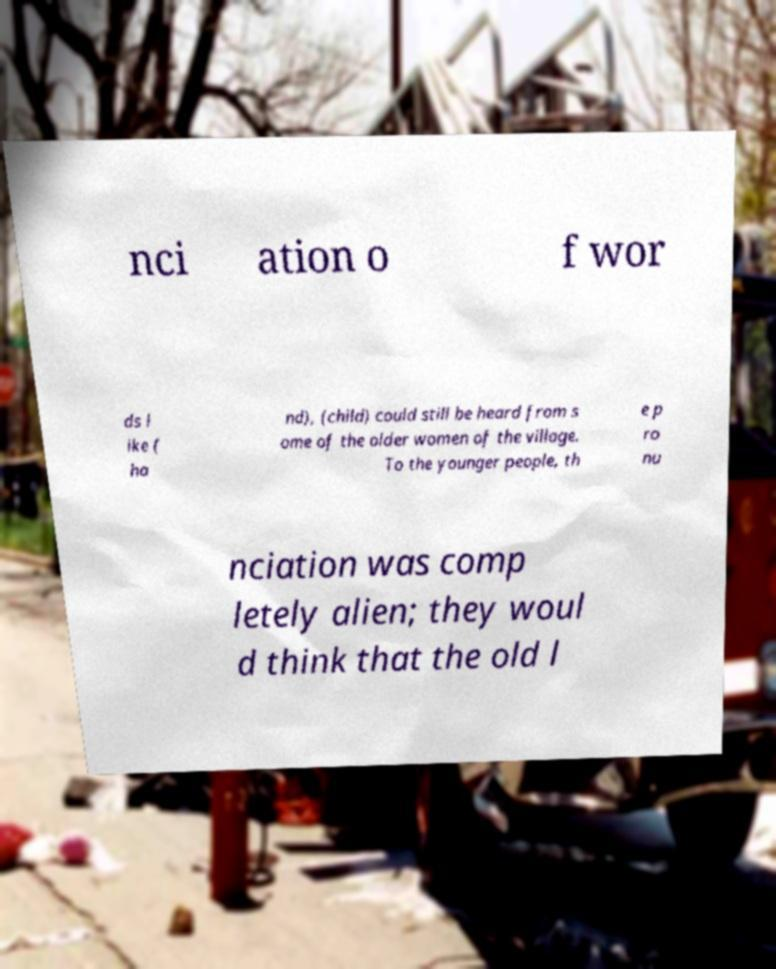Could you assist in decoding the text presented in this image and type it out clearly? nci ation o f wor ds l ike ( ha nd), (child) could still be heard from s ome of the older women of the village. To the younger people, th e p ro nu nciation was comp letely alien; they woul d think that the old l 